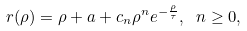<formula> <loc_0><loc_0><loc_500><loc_500>r ( \rho ) = \rho + a + c _ { n } \rho ^ { n } e ^ { - \frac { \rho } { \tau } } , \ n \geq 0 ,</formula> 